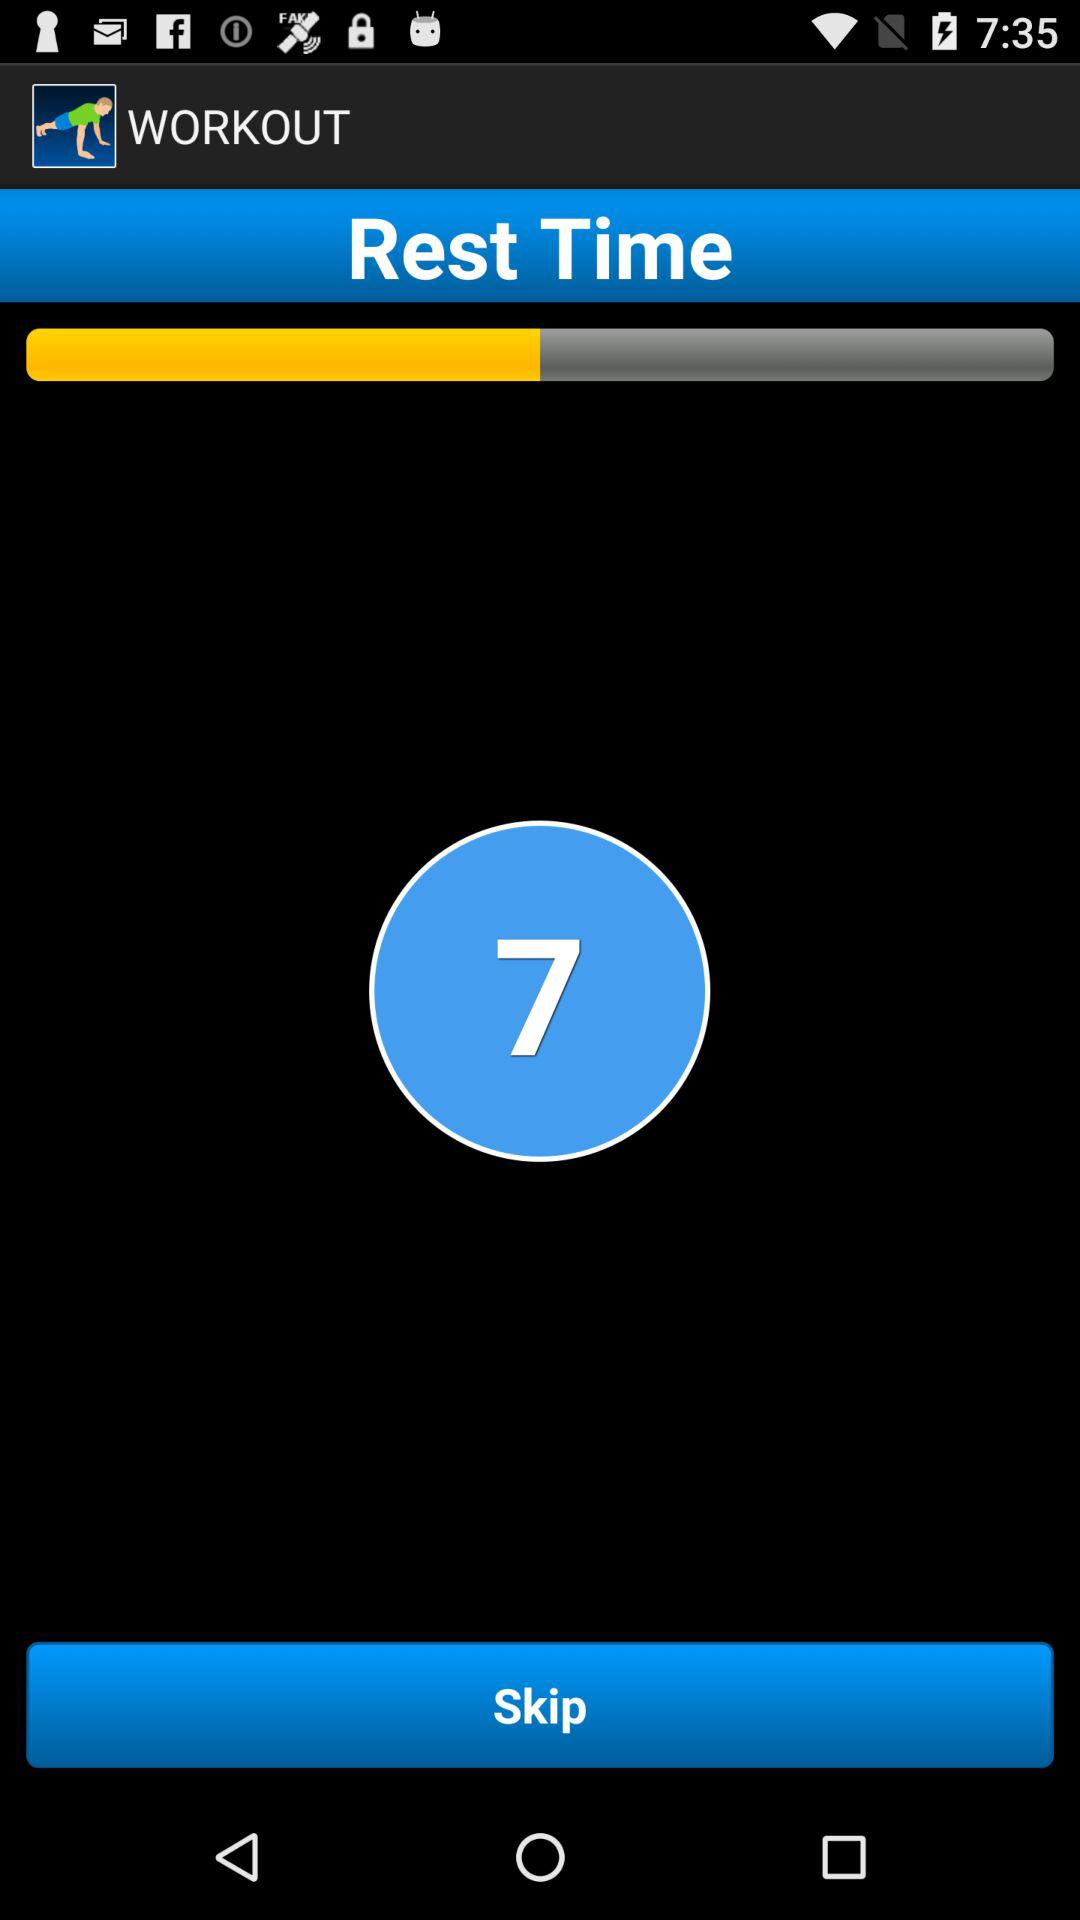What is the current rest time showing? The currently shown rest time is 7. 